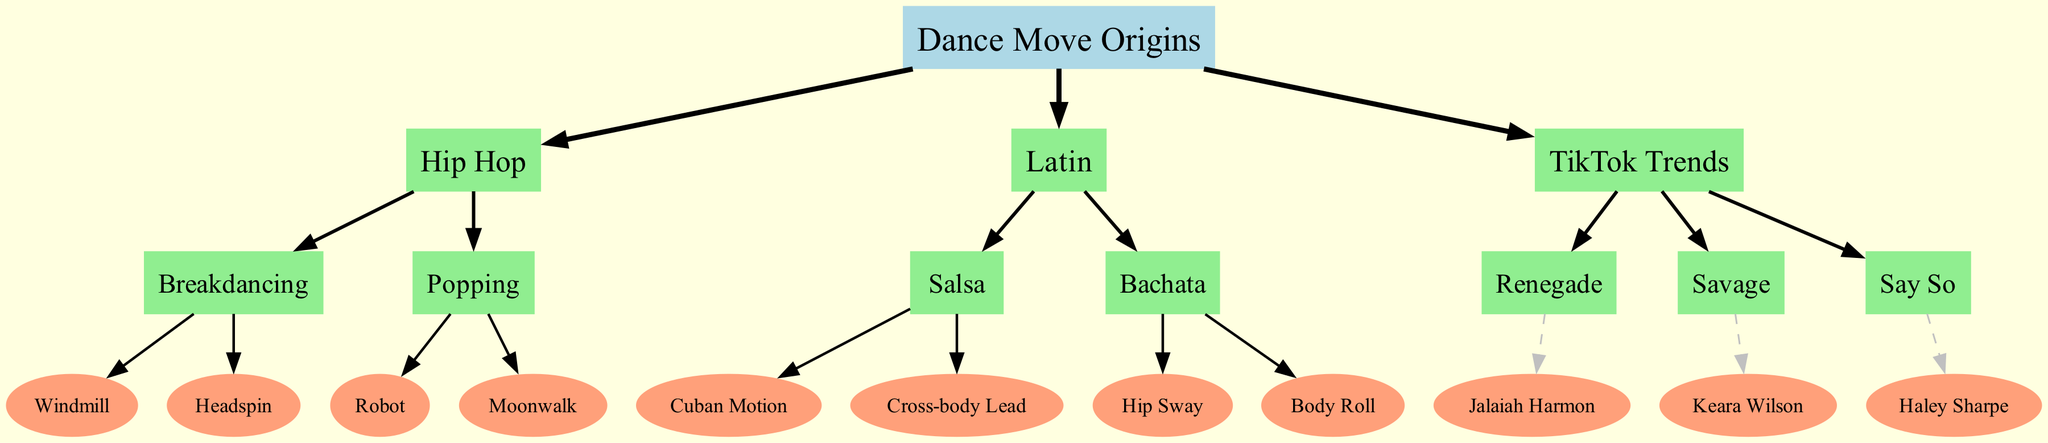What is the root node of the family tree? The root node is labeled "Dance Move Origins". It represents the starting point from which all other dance moves branch out.
Answer: Dance Move Origins How many main branches are there in the diagram? The diagram has three main branches labeled: Hip Hop, Latin, and TikTok Trends. Each branch represents a different category of dance moves.
Answer: 3 Which dance move is associated with Jalaiah Harmon? The dance move associated with Jalaiah Harmon is labeled "Renegade". It is shown under the TikTok Trends branch as her origin.
Answer: Renegade What type of move is "Salsa"? "Salsa" is categorized under the "Latin" branch of the family tree. It indicates that it belongs to a specific genre of dance moves.
Answer: Latin Which two dance moves are children of "Breakdancing"? The two dance moves that are children of "Breakdancing" are "Windmill" and "Headspin". This indicates that both moves originate from the Breakdancing category.
Answer: Windmill, Headspin How many children does the "Popping" branch have? The "Popping" branch has two children: "Robot" and "Moonwalk". This shows that there are two distinct dance moves under the Popping category.
Answer: 2 Which dance move demonstrates a body motion often seen in Bachata? The dance move demonstrating a body motion often seen in Bachata is "Body Roll". It is listed as one of the children under the Bachata category.
Answer: Body Roll What is the origin of the dance move "Savage"? The origin of the dance move "Savage" is Keara Wilson, as indicated directly under that dance move in the TikTok Trends branch.
Answer: Keara Wilson How many dance moves are under the "Latin" category? There are four dance moves under the "Latin" category, which are "Salsa", "Bachata", "Cuban Motion", and "Cross-body Lead".
Answer: 4 